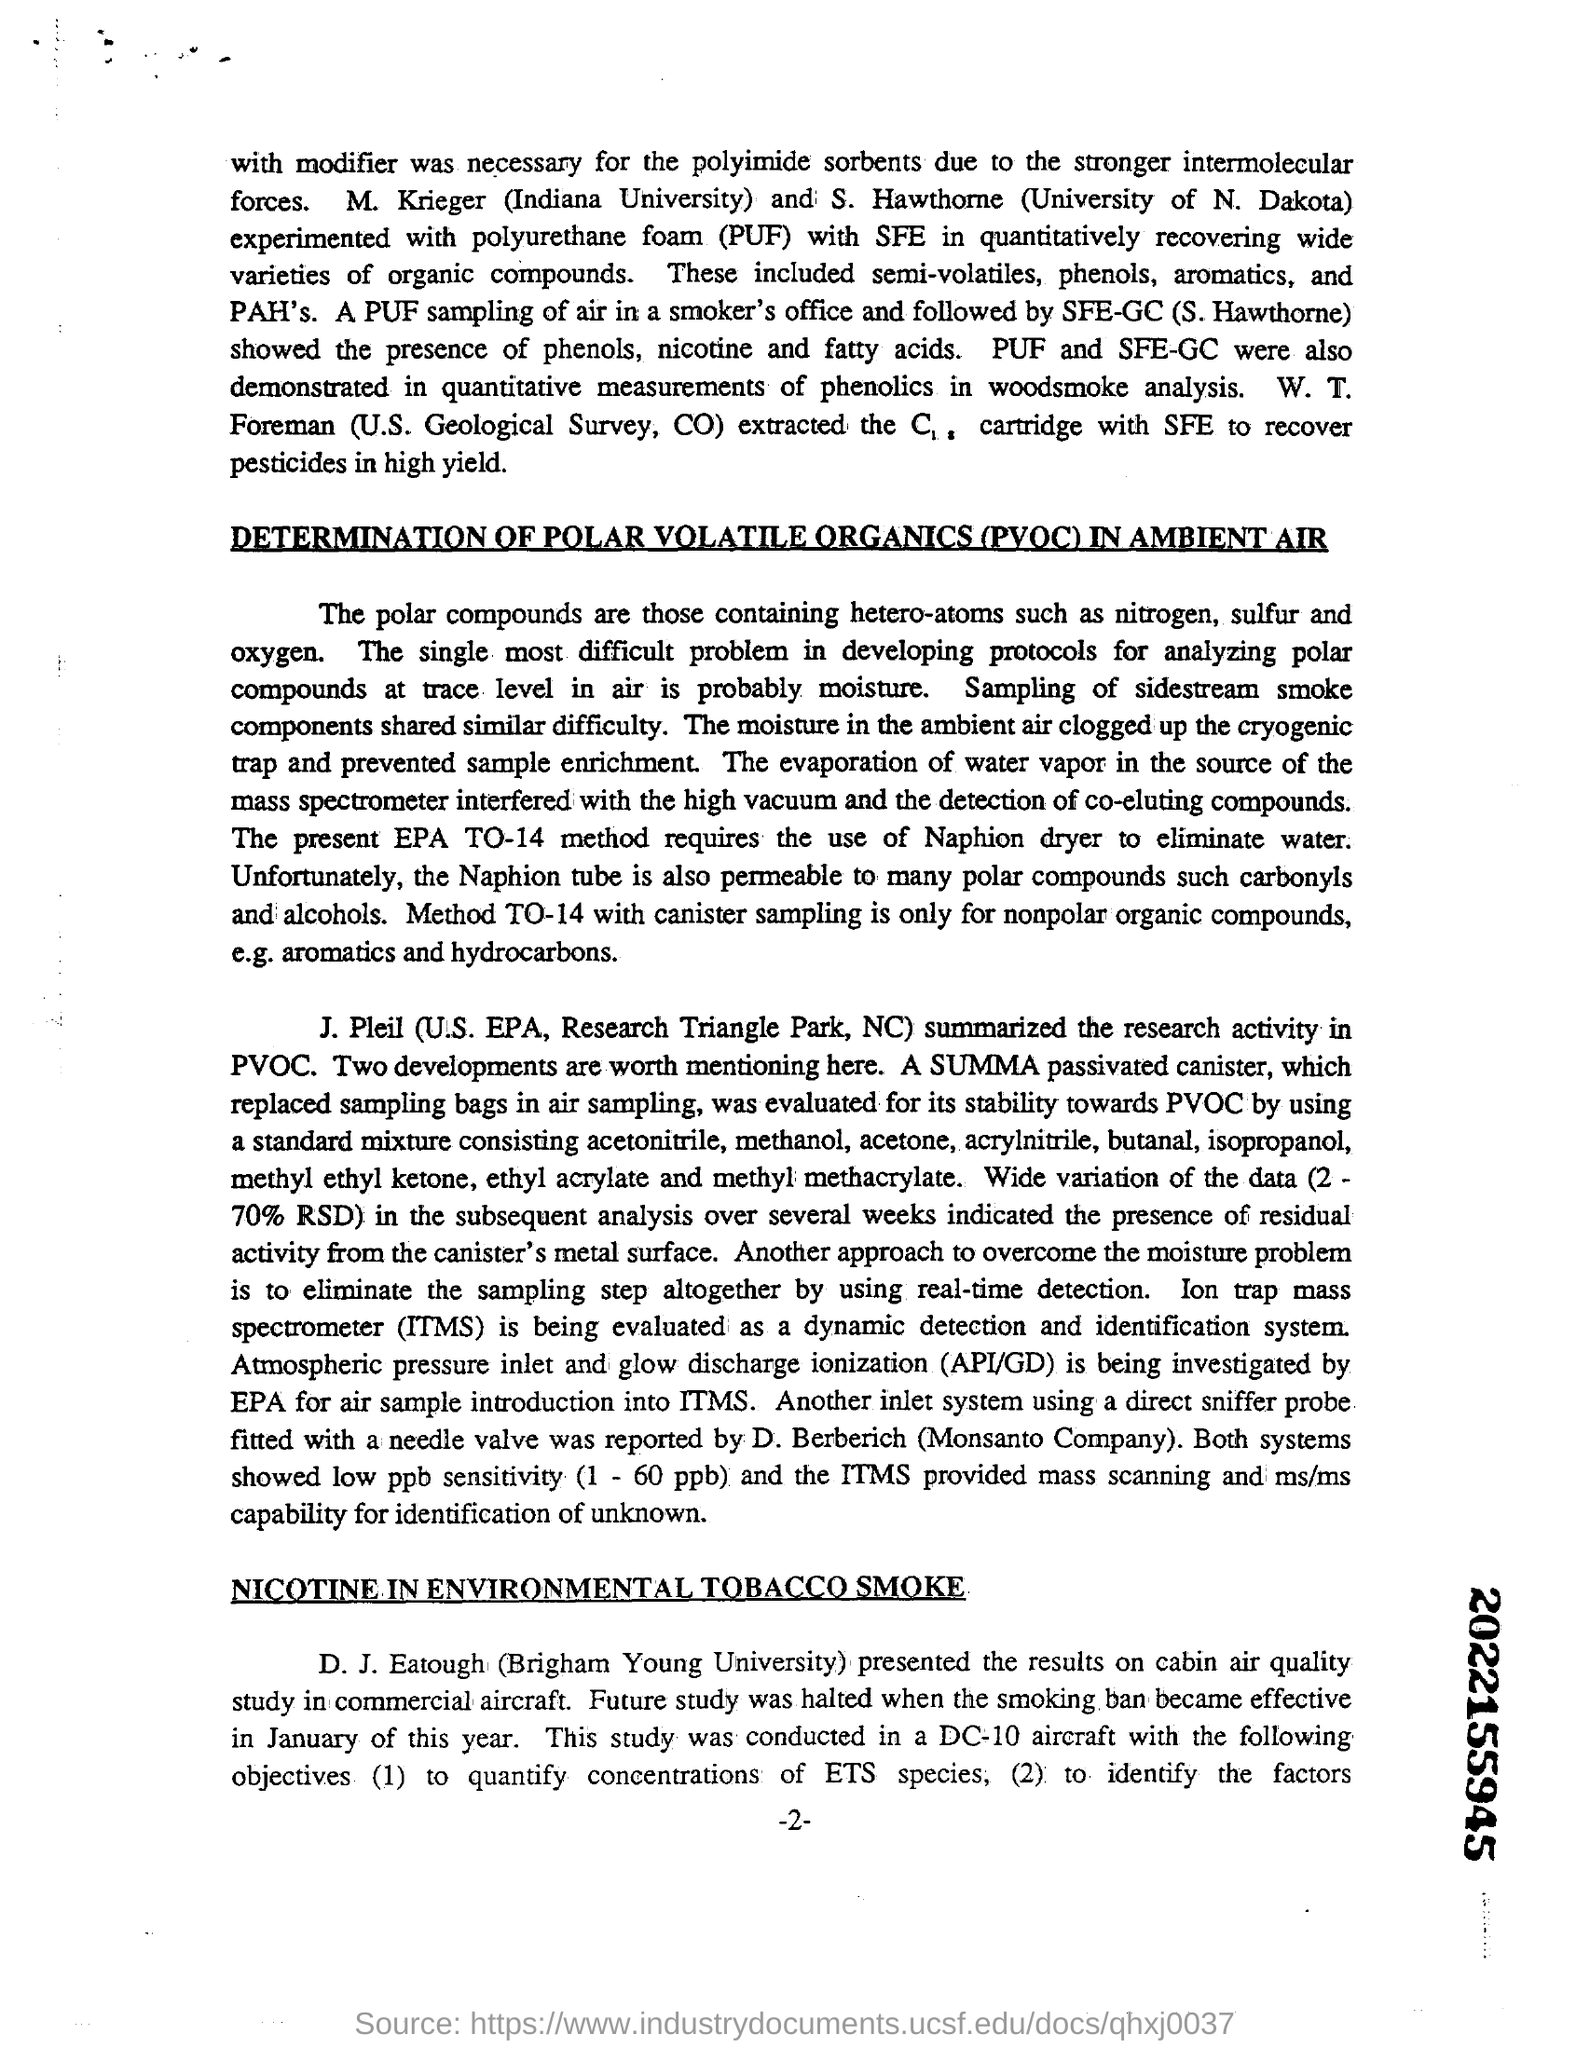Specify some key components in this picture. Polar compounds typically contain hetero-atoms such as nitrogen, sulfur, and oxygen. PUF stands for polyurethane foam, which is a type of plastic that is commonly used in insulation and other applications. The results of a study on cabin air quality in commercial aircraft were presented by D.J. Eatough. POVC stands for Polar Volatile Organics. 